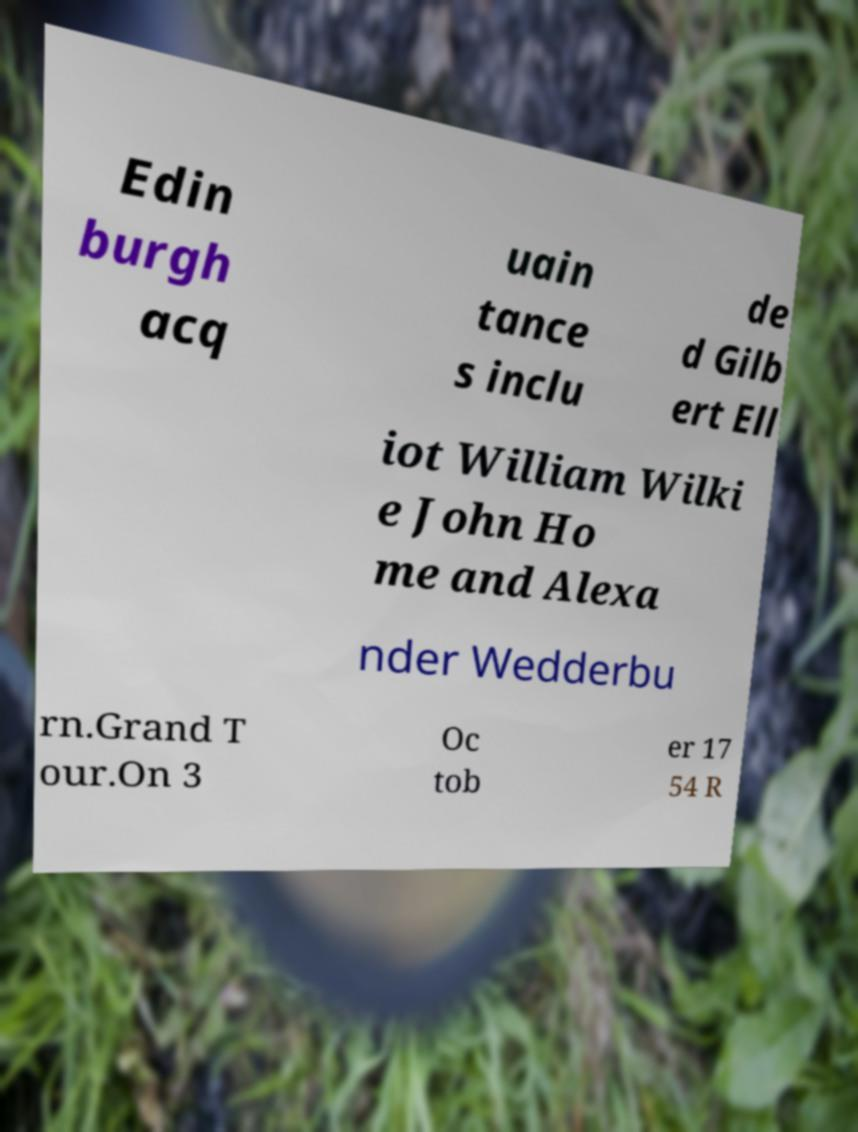I need the written content from this picture converted into text. Can you do that? Edin burgh acq uain tance s inclu de d Gilb ert Ell iot William Wilki e John Ho me and Alexa nder Wedderbu rn.Grand T our.On 3 Oc tob er 17 54 R 